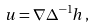<formula> <loc_0><loc_0><loc_500><loc_500>u = \nabla \Delta ^ { - 1 } h \, ,</formula> 